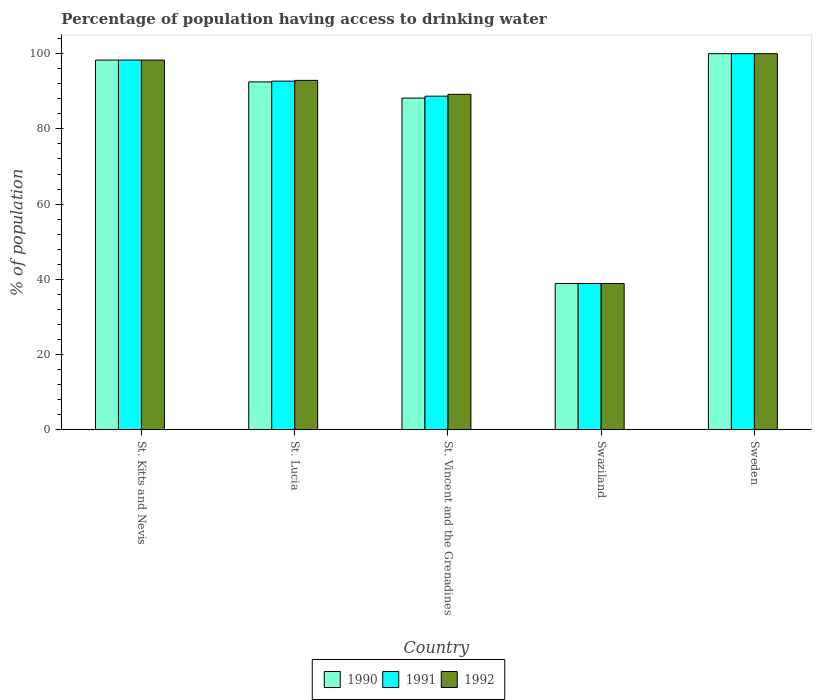How many different coloured bars are there?
Give a very brief answer. 3. How many groups of bars are there?
Your response must be concise. 5. Are the number of bars per tick equal to the number of legend labels?
Your answer should be very brief. Yes. Are the number of bars on each tick of the X-axis equal?
Your answer should be very brief. Yes. How many bars are there on the 3rd tick from the right?
Provide a short and direct response. 3. What is the label of the 1st group of bars from the left?
Provide a short and direct response. St. Kitts and Nevis. What is the percentage of population having access to drinking water in 1992 in Swaziland?
Keep it short and to the point. 38.9. Across all countries, what is the minimum percentage of population having access to drinking water in 1992?
Your response must be concise. 38.9. In which country was the percentage of population having access to drinking water in 1992 maximum?
Provide a short and direct response. Sweden. In which country was the percentage of population having access to drinking water in 1992 minimum?
Offer a terse response. Swaziland. What is the total percentage of population having access to drinking water in 1990 in the graph?
Offer a very short reply. 417.9. What is the difference between the percentage of population having access to drinking water in 1992 in St. Kitts and Nevis and that in Sweden?
Your response must be concise. -1.7. What is the difference between the percentage of population having access to drinking water in 1991 in St. Vincent and the Grenadines and the percentage of population having access to drinking water in 1992 in St. Lucia?
Give a very brief answer. -4.2. What is the average percentage of population having access to drinking water in 1992 per country?
Your response must be concise. 83.86. What is the difference between the percentage of population having access to drinking water of/in 1991 and percentage of population having access to drinking water of/in 1992 in Swaziland?
Give a very brief answer. 0. In how many countries, is the percentage of population having access to drinking water in 1992 greater than 48 %?
Your response must be concise. 4. What is the ratio of the percentage of population having access to drinking water in 1990 in St. Kitts and Nevis to that in Swaziland?
Offer a terse response. 2.53. What is the difference between the highest and the second highest percentage of population having access to drinking water in 1990?
Make the answer very short. -1.7. What is the difference between the highest and the lowest percentage of population having access to drinking water in 1991?
Your answer should be very brief. 61.1. In how many countries, is the percentage of population having access to drinking water in 1990 greater than the average percentage of population having access to drinking water in 1990 taken over all countries?
Offer a terse response. 4. Is it the case that in every country, the sum of the percentage of population having access to drinking water in 1991 and percentage of population having access to drinking water in 1990 is greater than the percentage of population having access to drinking water in 1992?
Provide a short and direct response. Yes. How many bars are there?
Give a very brief answer. 15. What is the difference between two consecutive major ticks on the Y-axis?
Your answer should be very brief. 20. Are the values on the major ticks of Y-axis written in scientific E-notation?
Give a very brief answer. No. Does the graph contain any zero values?
Provide a short and direct response. No. Where does the legend appear in the graph?
Your response must be concise. Bottom center. How are the legend labels stacked?
Offer a very short reply. Horizontal. What is the title of the graph?
Provide a succinct answer. Percentage of population having access to drinking water. What is the label or title of the Y-axis?
Give a very brief answer. % of population. What is the % of population of 1990 in St. Kitts and Nevis?
Keep it short and to the point. 98.3. What is the % of population of 1991 in St. Kitts and Nevis?
Make the answer very short. 98.3. What is the % of population of 1992 in St. Kitts and Nevis?
Offer a terse response. 98.3. What is the % of population in 1990 in St. Lucia?
Your answer should be very brief. 92.5. What is the % of population in 1991 in St. Lucia?
Offer a very short reply. 92.7. What is the % of population in 1992 in St. Lucia?
Provide a short and direct response. 92.9. What is the % of population of 1990 in St. Vincent and the Grenadines?
Give a very brief answer. 88.2. What is the % of population of 1991 in St. Vincent and the Grenadines?
Offer a very short reply. 88.7. What is the % of population in 1992 in St. Vincent and the Grenadines?
Offer a very short reply. 89.2. What is the % of population in 1990 in Swaziland?
Your response must be concise. 38.9. What is the % of population of 1991 in Swaziland?
Make the answer very short. 38.9. What is the % of population of 1992 in Swaziland?
Your response must be concise. 38.9. What is the % of population in 1990 in Sweden?
Your answer should be compact. 100. What is the % of population of 1991 in Sweden?
Provide a succinct answer. 100. What is the % of population in 1992 in Sweden?
Keep it short and to the point. 100. Across all countries, what is the maximum % of population of 1990?
Your answer should be compact. 100. Across all countries, what is the maximum % of population in 1991?
Your response must be concise. 100. Across all countries, what is the minimum % of population of 1990?
Provide a short and direct response. 38.9. Across all countries, what is the minimum % of population in 1991?
Ensure brevity in your answer.  38.9. Across all countries, what is the minimum % of population in 1992?
Your answer should be compact. 38.9. What is the total % of population in 1990 in the graph?
Offer a very short reply. 417.9. What is the total % of population of 1991 in the graph?
Provide a succinct answer. 418.6. What is the total % of population in 1992 in the graph?
Keep it short and to the point. 419.3. What is the difference between the % of population in 1990 in St. Kitts and Nevis and that in St. Lucia?
Keep it short and to the point. 5.8. What is the difference between the % of population of 1990 in St. Kitts and Nevis and that in St. Vincent and the Grenadines?
Ensure brevity in your answer.  10.1. What is the difference between the % of population in 1991 in St. Kitts and Nevis and that in St. Vincent and the Grenadines?
Your answer should be very brief. 9.6. What is the difference between the % of population of 1990 in St. Kitts and Nevis and that in Swaziland?
Make the answer very short. 59.4. What is the difference between the % of population of 1991 in St. Kitts and Nevis and that in Swaziland?
Your answer should be compact. 59.4. What is the difference between the % of population of 1992 in St. Kitts and Nevis and that in Swaziland?
Provide a succinct answer. 59.4. What is the difference between the % of population of 1990 in St. Kitts and Nevis and that in Sweden?
Offer a terse response. -1.7. What is the difference between the % of population of 1991 in St. Lucia and that in St. Vincent and the Grenadines?
Make the answer very short. 4. What is the difference between the % of population of 1992 in St. Lucia and that in St. Vincent and the Grenadines?
Make the answer very short. 3.7. What is the difference between the % of population in 1990 in St. Lucia and that in Swaziland?
Offer a very short reply. 53.6. What is the difference between the % of population of 1991 in St. Lucia and that in Swaziland?
Offer a terse response. 53.8. What is the difference between the % of population in 1991 in St. Lucia and that in Sweden?
Make the answer very short. -7.3. What is the difference between the % of population in 1990 in St. Vincent and the Grenadines and that in Swaziland?
Your answer should be compact. 49.3. What is the difference between the % of population in 1991 in St. Vincent and the Grenadines and that in Swaziland?
Keep it short and to the point. 49.8. What is the difference between the % of population of 1992 in St. Vincent and the Grenadines and that in Swaziland?
Offer a very short reply. 50.3. What is the difference between the % of population in 1990 in Swaziland and that in Sweden?
Give a very brief answer. -61.1. What is the difference between the % of population in 1991 in Swaziland and that in Sweden?
Your answer should be very brief. -61.1. What is the difference between the % of population of 1992 in Swaziland and that in Sweden?
Your answer should be compact. -61.1. What is the difference between the % of population of 1990 in St. Kitts and Nevis and the % of population of 1992 in St. Lucia?
Ensure brevity in your answer.  5.4. What is the difference between the % of population in 1991 in St. Kitts and Nevis and the % of population in 1992 in St. Lucia?
Your answer should be very brief. 5.4. What is the difference between the % of population of 1990 in St. Kitts and Nevis and the % of population of 1991 in St. Vincent and the Grenadines?
Make the answer very short. 9.6. What is the difference between the % of population of 1991 in St. Kitts and Nevis and the % of population of 1992 in St. Vincent and the Grenadines?
Provide a succinct answer. 9.1. What is the difference between the % of population in 1990 in St. Kitts and Nevis and the % of population in 1991 in Swaziland?
Offer a terse response. 59.4. What is the difference between the % of population of 1990 in St. Kitts and Nevis and the % of population of 1992 in Swaziland?
Your response must be concise. 59.4. What is the difference between the % of population in 1991 in St. Kitts and Nevis and the % of population in 1992 in Swaziland?
Provide a succinct answer. 59.4. What is the difference between the % of population in 1990 in St. Kitts and Nevis and the % of population in 1991 in Sweden?
Keep it short and to the point. -1.7. What is the difference between the % of population in 1990 in St. Kitts and Nevis and the % of population in 1992 in Sweden?
Keep it short and to the point. -1.7. What is the difference between the % of population in 1990 in St. Lucia and the % of population in 1991 in St. Vincent and the Grenadines?
Offer a very short reply. 3.8. What is the difference between the % of population in 1991 in St. Lucia and the % of population in 1992 in St. Vincent and the Grenadines?
Provide a short and direct response. 3.5. What is the difference between the % of population of 1990 in St. Lucia and the % of population of 1991 in Swaziland?
Provide a short and direct response. 53.6. What is the difference between the % of population of 1990 in St. Lucia and the % of population of 1992 in Swaziland?
Provide a short and direct response. 53.6. What is the difference between the % of population of 1991 in St. Lucia and the % of population of 1992 in Swaziland?
Keep it short and to the point. 53.8. What is the difference between the % of population in 1990 in St. Lucia and the % of population in 1991 in Sweden?
Offer a very short reply. -7.5. What is the difference between the % of population in 1990 in St. Lucia and the % of population in 1992 in Sweden?
Ensure brevity in your answer.  -7.5. What is the difference between the % of population of 1991 in St. Lucia and the % of population of 1992 in Sweden?
Provide a short and direct response. -7.3. What is the difference between the % of population of 1990 in St. Vincent and the Grenadines and the % of population of 1991 in Swaziland?
Offer a terse response. 49.3. What is the difference between the % of population in 1990 in St. Vincent and the Grenadines and the % of population in 1992 in Swaziland?
Provide a succinct answer. 49.3. What is the difference between the % of population in 1991 in St. Vincent and the Grenadines and the % of population in 1992 in Swaziland?
Make the answer very short. 49.8. What is the difference between the % of population in 1991 in St. Vincent and the Grenadines and the % of population in 1992 in Sweden?
Give a very brief answer. -11.3. What is the difference between the % of population of 1990 in Swaziland and the % of population of 1991 in Sweden?
Provide a succinct answer. -61.1. What is the difference between the % of population in 1990 in Swaziland and the % of population in 1992 in Sweden?
Your response must be concise. -61.1. What is the difference between the % of population of 1991 in Swaziland and the % of population of 1992 in Sweden?
Ensure brevity in your answer.  -61.1. What is the average % of population in 1990 per country?
Your response must be concise. 83.58. What is the average % of population in 1991 per country?
Make the answer very short. 83.72. What is the average % of population in 1992 per country?
Provide a short and direct response. 83.86. What is the difference between the % of population in 1990 and % of population in 1991 in St. Lucia?
Ensure brevity in your answer.  -0.2. What is the difference between the % of population of 1990 and % of population of 1992 in St. Lucia?
Ensure brevity in your answer.  -0.4. What is the difference between the % of population in 1990 and % of population in 1991 in St. Vincent and the Grenadines?
Your response must be concise. -0.5. What is the difference between the % of population in 1991 and % of population in 1992 in St. Vincent and the Grenadines?
Provide a short and direct response. -0.5. What is the difference between the % of population of 1990 and % of population of 1992 in Swaziland?
Your answer should be very brief. 0. What is the difference between the % of population in 1991 and % of population in 1992 in Sweden?
Offer a very short reply. 0. What is the ratio of the % of population of 1990 in St. Kitts and Nevis to that in St. Lucia?
Provide a short and direct response. 1.06. What is the ratio of the % of population in 1991 in St. Kitts and Nevis to that in St. Lucia?
Ensure brevity in your answer.  1.06. What is the ratio of the % of population in 1992 in St. Kitts and Nevis to that in St. Lucia?
Give a very brief answer. 1.06. What is the ratio of the % of population in 1990 in St. Kitts and Nevis to that in St. Vincent and the Grenadines?
Provide a succinct answer. 1.11. What is the ratio of the % of population in 1991 in St. Kitts and Nevis to that in St. Vincent and the Grenadines?
Offer a terse response. 1.11. What is the ratio of the % of population in 1992 in St. Kitts and Nevis to that in St. Vincent and the Grenadines?
Your response must be concise. 1.1. What is the ratio of the % of population of 1990 in St. Kitts and Nevis to that in Swaziland?
Provide a short and direct response. 2.53. What is the ratio of the % of population of 1991 in St. Kitts and Nevis to that in Swaziland?
Ensure brevity in your answer.  2.53. What is the ratio of the % of population of 1992 in St. Kitts and Nevis to that in Swaziland?
Your answer should be compact. 2.53. What is the ratio of the % of population of 1990 in St. Kitts and Nevis to that in Sweden?
Your response must be concise. 0.98. What is the ratio of the % of population in 1992 in St. Kitts and Nevis to that in Sweden?
Your answer should be very brief. 0.98. What is the ratio of the % of population of 1990 in St. Lucia to that in St. Vincent and the Grenadines?
Your response must be concise. 1.05. What is the ratio of the % of population of 1991 in St. Lucia to that in St. Vincent and the Grenadines?
Offer a terse response. 1.05. What is the ratio of the % of population of 1992 in St. Lucia to that in St. Vincent and the Grenadines?
Offer a very short reply. 1.04. What is the ratio of the % of population in 1990 in St. Lucia to that in Swaziland?
Offer a very short reply. 2.38. What is the ratio of the % of population of 1991 in St. Lucia to that in Swaziland?
Your response must be concise. 2.38. What is the ratio of the % of population in 1992 in St. Lucia to that in Swaziland?
Keep it short and to the point. 2.39. What is the ratio of the % of population of 1990 in St. Lucia to that in Sweden?
Provide a short and direct response. 0.93. What is the ratio of the % of population in 1991 in St. Lucia to that in Sweden?
Give a very brief answer. 0.93. What is the ratio of the % of population in 1992 in St. Lucia to that in Sweden?
Your answer should be compact. 0.93. What is the ratio of the % of population of 1990 in St. Vincent and the Grenadines to that in Swaziland?
Provide a succinct answer. 2.27. What is the ratio of the % of population of 1991 in St. Vincent and the Grenadines to that in Swaziland?
Provide a succinct answer. 2.28. What is the ratio of the % of population of 1992 in St. Vincent and the Grenadines to that in Swaziland?
Offer a very short reply. 2.29. What is the ratio of the % of population of 1990 in St. Vincent and the Grenadines to that in Sweden?
Provide a succinct answer. 0.88. What is the ratio of the % of population in 1991 in St. Vincent and the Grenadines to that in Sweden?
Provide a short and direct response. 0.89. What is the ratio of the % of population of 1992 in St. Vincent and the Grenadines to that in Sweden?
Your answer should be compact. 0.89. What is the ratio of the % of population of 1990 in Swaziland to that in Sweden?
Your answer should be compact. 0.39. What is the ratio of the % of population of 1991 in Swaziland to that in Sweden?
Keep it short and to the point. 0.39. What is the ratio of the % of population in 1992 in Swaziland to that in Sweden?
Your response must be concise. 0.39. What is the difference between the highest and the second highest % of population in 1990?
Keep it short and to the point. 1.7. What is the difference between the highest and the second highest % of population of 1991?
Provide a succinct answer. 1.7. What is the difference between the highest and the lowest % of population of 1990?
Your response must be concise. 61.1. What is the difference between the highest and the lowest % of population of 1991?
Offer a very short reply. 61.1. What is the difference between the highest and the lowest % of population of 1992?
Give a very brief answer. 61.1. 